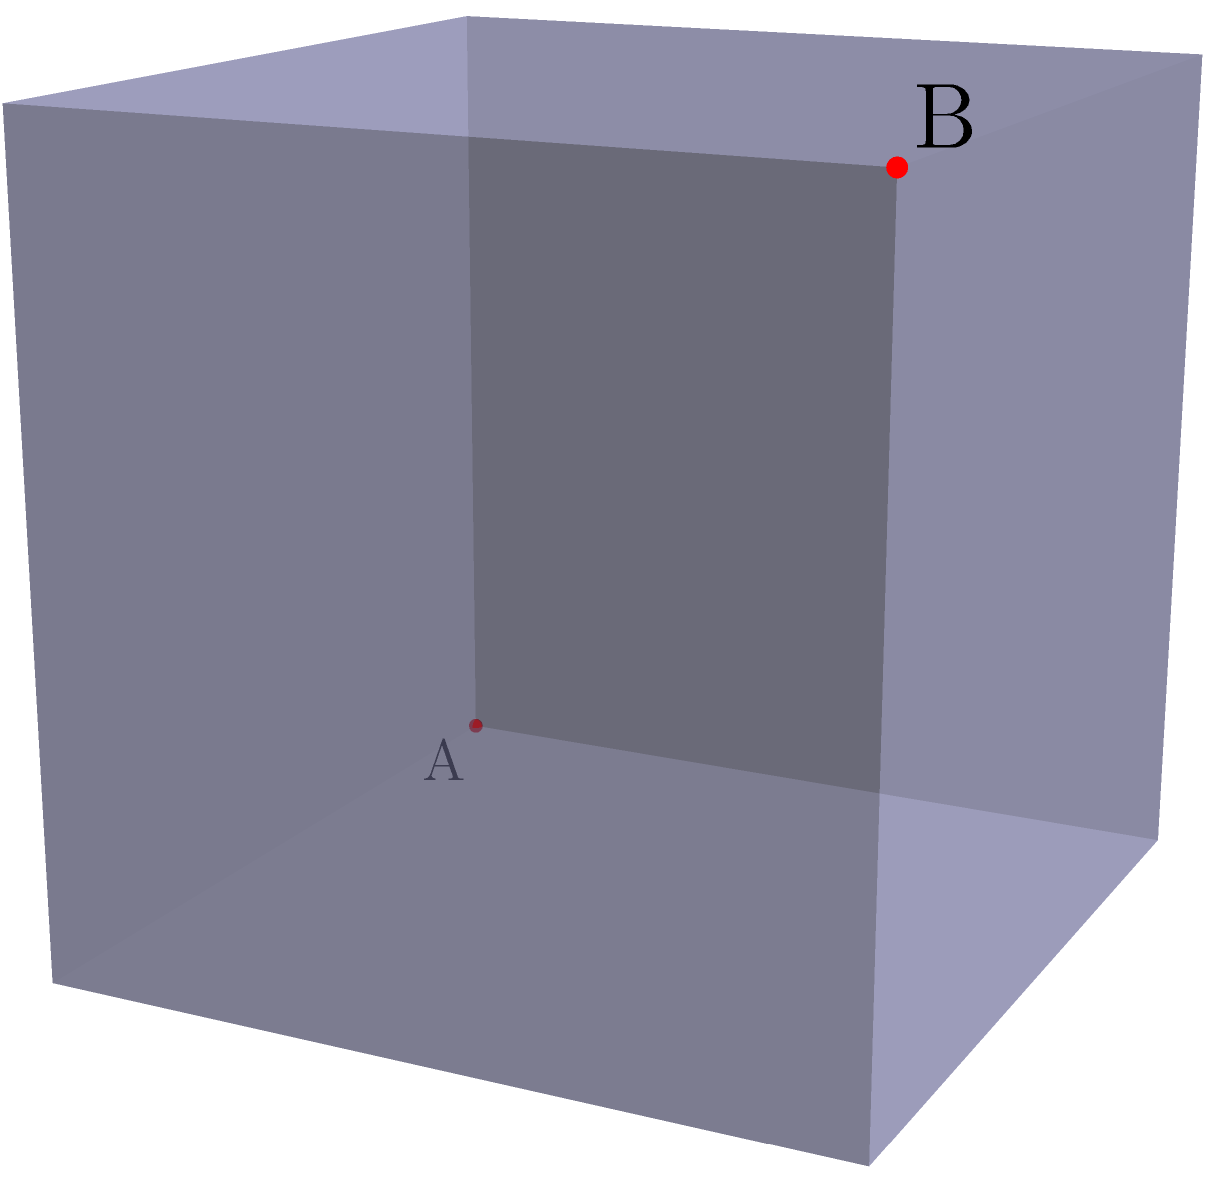Given a cube with side length 2 units and two points A and B located at opposite corners of the cube, what is the length of the shortest path between these points when the cube is unfolded into a plane? Assume that the path can only travel along the surface of the cube. To solve this problem, we'll follow these steps:

1) First, let's understand what the unfolded cube looks like. In the diagram, we can see that point A is at (0,0) and point B is at (4,2) in the unfolded 2D representation.

2) The shortest path between two points on a plane is always a straight line. So, in the unfolded representation, the shortest path is the straight line from A to B.

3) To find the length of this line, we can use the Pythagorean theorem:

   $$length = \sqrt{(x_2-x_1)^2 + (y_2-y_1)^2}$$

   where $(x_1,y_1)$ is the coordinate of A (0,0) and $(x_2,y_2)$ is the coordinate of B (4,2).

4) Plugging in the values:

   $$length = \sqrt{(4-0)^2 + (2-0)^2} = \sqrt{16 + 4} = \sqrt{20}$$

5) Simplify:

   $$length = 2\sqrt{5}$$

6) This length is in units of the cube's side length. Since the cube's side length is 2 units, we multiply our result by 2:

   $$final\_length = 2 * 2\sqrt{5} = 4\sqrt{5}$$

Therefore, the shortest path between points A and B on the surface of the cube, when unfolded into a plane, is $4\sqrt{5}$ units long.
Answer: $4\sqrt{5}$ units 